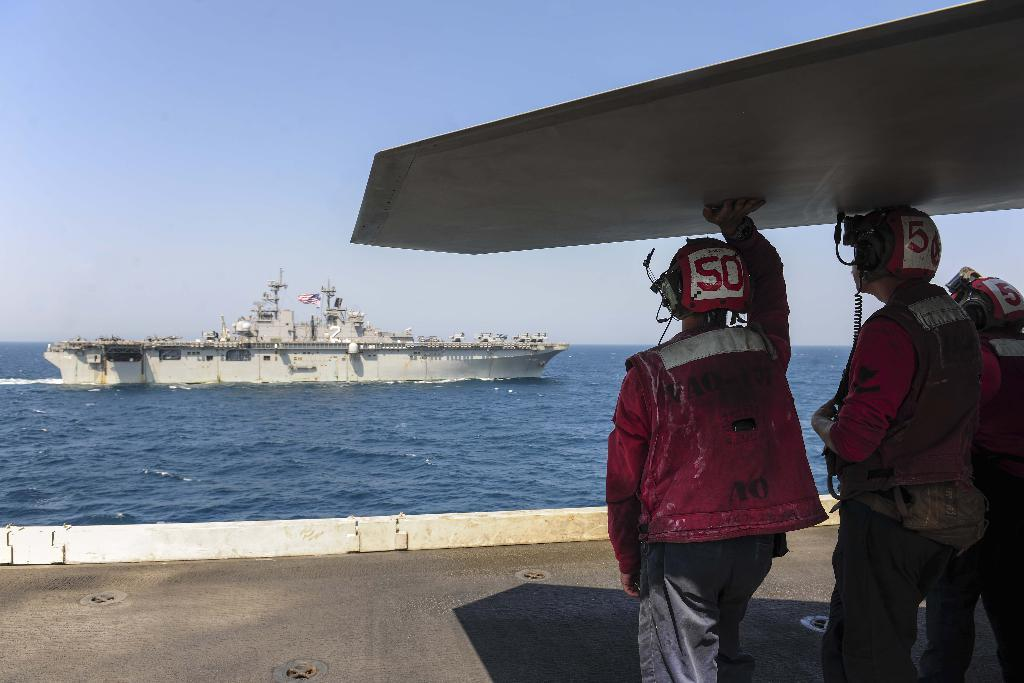Provide a one-sentence caption for the provided image. Two men with helmets on a ship with the number 50 on the helmets. 